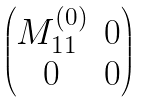Convert formula to latex. <formula><loc_0><loc_0><loc_500><loc_500>\begin{pmatrix} M _ { 1 1 } ^ { ( 0 ) } & 0 \\ 0 & 0 \end{pmatrix}</formula> 